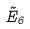Convert formula to latex. <formula><loc_0><loc_0><loc_500><loc_500>\tilde { E } _ { 6 }</formula> 